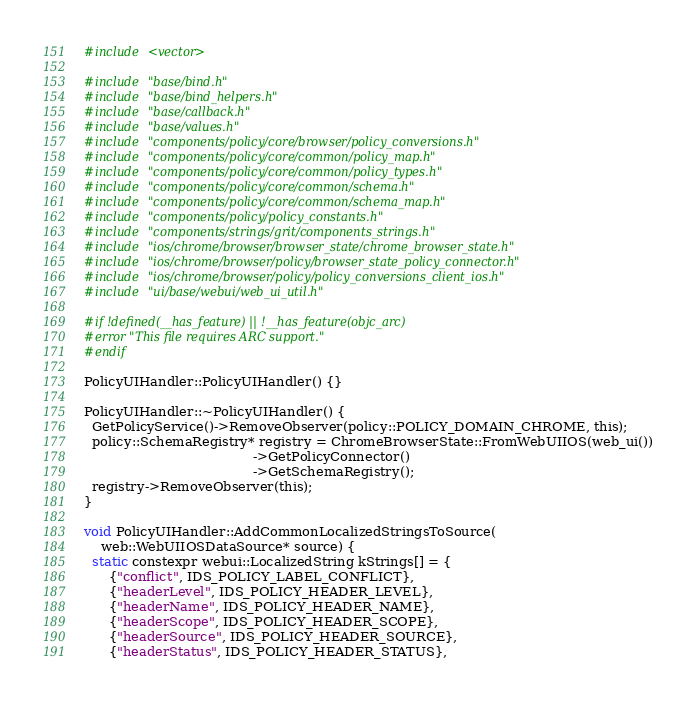<code> <loc_0><loc_0><loc_500><loc_500><_ObjectiveC_>#include <vector>

#include "base/bind.h"
#include "base/bind_helpers.h"
#include "base/callback.h"
#include "base/values.h"
#include "components/policy/core/browser/policy_conversions.h"
#include "components/policy/core/common/policy_map.h"
#include "components/policy/core/common/policy_types.h"
#include "components/policy/core/common/schema.h"
#include "components/policy/core/common/schema_map.h"
#include "components/policy/policy_constants.h"
#include "components/strings/grit/components_strings.h"
#include "ios/chrome/browser/browser_state/chrome_browser_state.h"
#include "ios/chrome/browser/policy/browser_state_policy_connector.h"
#include "ios/chrome/browser/policy/policy_conversions_client_ios.h"
#include "ui/base/webui/web_ui_util.h"

#if !defined(__has_feature) || !__has_feature(objc_arc)
#error "This file requires ARC support."
#endif

PolicyUIHandler::PolicyUIHandler() {}

PolicyUIHandler::~PolicyUIHandler() {
  GetPolicyService()->RemoveObserver(policy::POLICY_DOMAIN_CHROME, this);
  policy::SchemaRegistry* registry = ChromeBrowserState::FromWebUIIOS(web_ui())
                                         ->GetPolicyConnector()
                                         ->GetSchemaRegistry();
  registry->RemoveObserver(this);
}

void PolicyUIHandler::AddCommonLocalizedStringsToSource(
    web::WebUIIOSDataSource* source) {
  static constexpr webui::LocalizedString kStrings[] = {
      {"conflict", IDS_POLICY_LABEL_CONFLICT},
      {"headerLevel", IDS_POLICY_HEADER_LEVEL},
      {"headerName", IDS_POLICY_HEADER_NAME},
      {"headerScope", IDS_POLICY_HEADER_SCOPE},
      {"headerSource", IDS_POLICY_HEADER_SOURCE},
      {"headerStatus", IDS_POLICY_HEADER_STATUS},</code> 